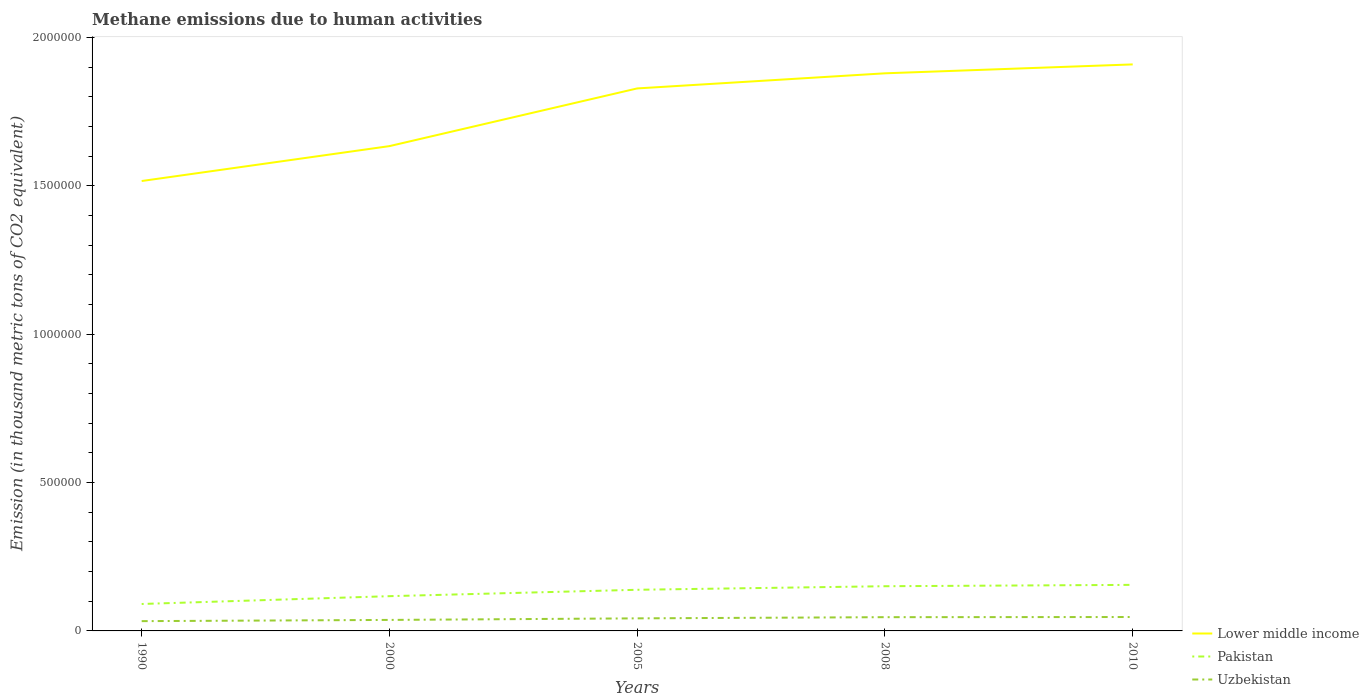How many different coloured lines are there?
Your answer should be very brief. 3. Does the line corresponding to Pakistan intersect with the line corresponding to Lower middle income?
Provide a short and direct response. No. Is the number of lines equal to the number of legend labels?
Offer a very short reply. Yes. Across all years, what is the maximum amount of methane emitted in Lower middle income?
Offer a terse response. 1.52e+06. What is the total amount of methane emitted in Lower middle income in the graph?
Your response must be concise. -2.75e+05. What is the difference between the highest and the second highest amount of methane emitted in Pakistan?
Offer a terse response. 6.44e+04. How many lines are there?
Ensure brevity in your answer.  3. What is the difference between two consecutive major ticks on the Y-axis?
Your response must be concise. 5.00e+05. Does the graph contain any zero values?
Offer a very short reply. No. Where does the legend appear in the graph?
Make the answer very short. Bottom right. What is the title of the graph?
Keep it short and to the point. Methane emissions due to human activities. What is the label or title of the X-axis?
Keep it short and to the point. Years. What is the label or title of the Y-axis?
Provide a short and direct response. Emission (in thousand metric tons of CO2 equivalent). What is the Emission (in thousand metric tons of CO2 equivalent) of Lower middle income in 1990?
Make the answer very short. 1.52e+06. What is the Emission (in thousand metric tons of CO2 equivalent) in Pakistan in 1990?
Keep it short and to the point. 9.08e+04. What is the Emission (in thousand metric tons of CO2 equivalent) in Uzbekistan in 1990?
Your answer should be compact. 3.29e+04. What is the Emission (in thousand metric tons of CO2 equivalent) in Lower middle income in 2000?
Make the answer very short. 1.63e+06. What is the Emission (in thousand metric tons of CO2 equivalent) of Pakistan in 2000?
Your response must be concise. 1.17e+05. What is the Emission (in thousand metric tons of CO2 equivalent) in Uzbekistan in 2000?
Your answer should be compact. 3.71e+04. What is the Emission (in thousand metric tons of CO2 equivalent) of Lower middle income in 2005?
Your answer should be compact. 1.83e+06. What is the Emission (in thousand metric tons of CO2 equivalent) of Pakistan in 2005?
Your answer should be compact. 1.39e+05. What is the Emission (in thousand metric tons of CO2 equivalent) of Uzbekistan in 2005?
Offer a terse response. 4.24e+04. What is the Emission (in thousand metric tons of CO2 equivalent) in Lower middle income in 2008?
Keep it short and to the point. 1.88e+06. What is the Emission (in thousand metric tons of CO2 equivalent) of Pakistan in 2008?
Your answer should be very brief. 1.51e+05. What is the Emission (in thousand metric tons of CO2 equivalent) in Uzbekistan in 2008?
Your answer should be compact. 4.63e+04. What is the Emission (in thousand metric tons of CO2 equivalent) in Lower middle income in 2010?
Provide a short and direct response. 1.91e+06. What is the Emission (in thousand metric tons of CO2 equivalent) of Pakistan in 2010?
Make the answer very short. 1.55e+05. What is the Emission (in thousand metric tons of CO2 equivalent) in Uzbekistan in 2010?
Your answer should be compact. 4.69e+04. Across all years, what is the maximum Emission (in thousand metric tons of CO2 equivalent) in Lower middle income?
Provide a short and direct response. 1.91e+06. Across all years, what is the maximum Emission (in thousand metric tons of CO2 equivalent) in Pakistan?
Your answer should be very brief. 1.55e+05. Across all years, what is the maximum Emission (in thousand metric tons of CO2 equivalent) of Uzbekistan?
Give a very brief answer. 4.69e+04. Across all years, what is the minimum Emission (in thousand metric tons of CO2 equivalent) in Lower middle income?
Make the answer very short. 1.52e+06. Across all years, what is the minimum Emission (in thousand metric tons of CO2 equivalent) of Pakistan?
Offer a terse response. 9.08e+04. Across all years, what is the minimum Emission (in thousand metric tons of CO2 equivalent) in Uzbekistan?
Offer a terse response. 3.29e+04. What is the total Emission (in thousand metric tons of CO2 equivalent) in Lower middle income in the graph?
Provide a succinct answer. 8.77e+06. What is the total Emission (in thousand metric tons of CO2 equivalent) of Pakistan in the graph?
Ensure brevity in your answer.  6.52e+05. What is the total Emission (in thousand metric tons of CO2 equivalent) of Uzbekistan in the graph?
Your response must be concise. 2.06e+05. What is the difference between the Emission (in thousand metric tons of CO2 equivalent) in Lower middle income in 1990 and that in 2000?
Make the answer very short. -1.18e+05. What is the difference between the Emission (in thousand metric tons of CO2 equivalent) of Pakistan in 1990 and that in 2000?
Your answer should be very brief. -2.63e+04. What is the difference between the Emission (in thousand metric tons of CO2 equivalent) of Uzbekistan in 1990 and that in 2000?
Provide a succinct answer. -4131.6. What is the difference between the Emission (in thousand metric tons of CO2 equivalent) of Lower middle income in 1990 and that in 2005?
Provide a short and direct response. -3.12e+05. What is the difference between the Emission (in thousand metric tons of CO2 equivalent) of Pakistan in 1990 and that in 2005?
Make the answer very short. -4.79e+04. What is the difference between the Emission (in thousand metric tons of CO2 equivalent) in Uzbekistan in 1990 and that in 2005?
Give a very brief answer. -9405.4. What is the difference between the Emission (in thousand metric tons of CO2 equivalent) of Lower middle income in 1990 and that in 2008?
Ensure brevity in your answer.  -3.63e+05. What is the difference between the Emission (in thousand metric tons of CO2 equivalent) in Pakistan in 1990 and that in 2008?
Your answer should be compact. -5.98e+04. What is the difference between the Emission (in thousand metric tons of CO2 equivalent) of Uzbekistan in 1990 and that in 2008?
Provide a short and direct response. -1.34e+04. What is the difference between the Emission (in thousand metric tons of CO2 equivalent) of Lower middle income in 1990 and that in 2010?
Offer a terse response. -3.93e+05. What is the difference between the Emission (in thousand metric tons of CO2 equivalent) of Pakistan in 1990 and that in 2010?
Offer a terse response. -6.44e+04. What is the difference between the Emission (in thousand metric tons of CO2 equivalent) of Uzbekistan in 1990 and that in 2010?
Your answer should be compact. -1.39e+04. What is the difference between the Emission (in thousand metric tons of CO2 equivalent) of Lower middle income in 2000 and that in 2005?
Give a very brief answer. -1.94e+05. What is the difference between the Emission (in thousand metric tons of CO2 equivalent) in Pakistan in 2000 and that in 2005?
Your answer should be compact. -2.15e+04. What is the difference between the Emission (in thousand metric tons of CO2 equivalent) in Uzbekistan in 2000 and that in 2005?
Your response must be concise. -5273.8. What is the difference between the Emission (in thousand metric tons of CO2 equivalent) in Lower middle income in 2000 and that in 2008?
Make the answer very short. -2.45e+05. What is the difference between the Emission (in thousand metric tons of CO2 equivalent) of Pakistan in 2000 and that in 2008?
Offer a terse response. -3.35e+04. What is the difference between the Emission (in thousand metric tons of CO2 equivalent) in Uzbekistan in 2000 and that in 2008?
Give a very brief answer. -9259.7. What is the difference between the Emission (in thousand metric tons of CO2 equivalent) in Lower middle income in 2000 and that in 2010?
Your response must be concise. -2.75e+05. What is the difference between the Emission (in thousand metric tons of CO2 equivalent) of Pakistan in 2000 and that in 2010?
Keep it short and to the point. -3.81e+04. What is the difference between the Emission (in thousand metric tons of CO2 equivalent) of Uzbekistan in 2000 and that in 2010?
Offer a terse response. -9783.1. What is the difference between the Emission (in thousand metric tons of CO2 equivalent) in Lower middle income in 2005 and that in 2008?
Keep it short and to the point. -5.09e+04. What is the difference between the Emission (in thousand metric tons of CO2 equivalent) of Pakistan in 2005 and that in 2008?
Offer a very short reply. -1.20e+04. What is the difference between the Emission (in thousand metric tons of CO2 equivalent) of Uzbekistan in 2005 and that in 2008?
Ensure brevity in your answer.  -3985.9. What is the difference between the Emission (in thousand metric tons of CO2 equivalent) of Lower middle income in 2005 and that in 2010?
Make the answer very short. -8.09e+04. What is the difference between the Emission (in thousand metric tons of CO2 equivalent) in Pakistan in 2005 and that in 2010?
Give a very brief answer. -1.66e+04. What is the difference between the Emission (in thousand metric tons of CO2 equivalent) of Uzbekistan in 2005 and that in 2010?
Ensure brevity in your answer.  -4509.3. What is the difference between the Emission (in thousand metric tons of CO2 equivalent) of Lower middle income in 2008 and that in 2010?
Offer a terse response. -3.00e+04. What is the difference between the Emission (in thousand metric tons of CO2 equivalent) in Pakistan in 2008 and that in 2010?
Your answer should be very brief. -4592.5. What is the difference between the Emission (in thousand metric tons of CO2 equivalent) of Uzbekistan in 2008 and that in 2010?
Your answer should be very brief. -523.4. What is the difference between the Emission (in thousand metric tons of CO2 equivalent) of Lower middle income in 1990 and the Emission (in thousand metric tons of CO2 equivalent) of Pakistan in 2000?
Your answer should be compact. 1.40e+06. What is the difference between the Emission (in thousand metric tons of CO2 equivalent) of Lower middle income in 1990 and the Emission (in thousand metric tons of CO2 equivalent) of Uzbekistan in 2000?
Offer a terse response. 1.48e+06. What is the difference between the Emission (in thousand metric tons of CO2 equivalent) of Pakistan in 1990 and the Emission (in thousand metric tons of CO2 equivalent) of Uzbekistan in 2000?
Provide a short and direct response. 5.37e+04. What is the difference between the Emission (in thousand metric tons of CO2 equivalent) of Lower middle income in 1990 and the Emission (in thousand metric tons of CO2 equivalent) of Pakistan in 2005?
Provide a short and direct response. 1.38e+06. What is the difference between the Emission (in thousand metric tons of CO2 equivalent) in Lower middle income in 1990 and the Emission (in thousand metric tons of CO2 equivalent) in Uzbekistan in 2005?
Provide a succinct answer. 1.47e+06. What is the difference between the Emission (in thousand metric tons of CO2 equivalent) of Pakistan in 1990 and the Emission (in thousand metric tons of CO2 equivalent) of Uzbekistan in 2005?
Give a very brief answer. 4.85e+04. What is the difference between the Emission (in thousand metric tons of CO2 equivalent) of Lower middle income in 1990 and the Emission (in thousand metric tons of CO2 equivalent) of Pakistan in 2008?
Your answer should be very brief. 1.37e+06. What is the difference between the Emission (in thousand metric tons of CO2 equivalent) in Lower middle income in 1990 and the Emission (in thousand metric tons of CO2 equivalent) in Uzbekistan in 2008?
Offer a terse response. 1.47e+06. What is the difference between the Emission (in thousand metric tons of CO2 equivalent) of Pakistan in 1990 and the Emission (in thousand metric tons of CO2 equivalent) of Uzbekistan in 2008?
Offer a terse response. 4.45e+04. What is the difference between the Emission (in thousand metric tons of CO2 equivalent) in Lower middle income in 1990 and the Emission (in thousand metric tons of CO2 equivalent) in Pakistan in 2010?
Offer a terse response. 1.36e+06. What is the difference between the Emission (in thousand metric tons of CO2 equivalent) in Lower middle income in 1990 and the Emission (in thousand metric tons of CO2 equivalent) in Uzbekistan in 2010?
Keep it short and to the point. 1.47e+06. What is the difference between the Emission (in thousand metric tons of CO2 equivalent) of Pakistan in 1990 and the Emission (in thousand metric tons of CO2 equivalent) of Uzbekistan in 2010?
Your response must be concise. 4.39e+04. What is the difference between the Emission (in thousand metric tons of CO2 equivalent) of Lower middle income in 2000 and the Emission (in thousand metric tons of CO2 equivalent) of Pakistan in 2005?
Your response must be concise. 1.50e+06. What is the difference between the Emission (in thousand metric tons of CO2 equivalent) in Lower middle income in 2000 and the Emission (in thousand metric tons of CO2 equivalent) in Uzbekistan in 2005?
Your answer should be compact. 1.59e+06. What is the difference between the Emission (in thousand metric tons of CO2 equivalent) in Pakistan in 2000 and the Emission (in thousand metric tons of CO2 equivalent) in Uzbekistan in 2005?
Your answer should be very brief. 7.48e+04. What is the difference between the Emission (in thousand metric tons of CO2 equivalent) in Lower middle income in 2000 and the Emission (in thousand metric tons of CO2 equivalent) in Pakistan in 2008?
Ensure brevity in your answer.  1.48e+06. What is the difference between the Emission (in thousand metric tons of CO2 equivalent) of Lower middle income in 2000 and the Emission (in thousand metric tons of CO2 equivalent) of Uzbekistan in 2008?
Offer a very short reply. 1.59e+06. What is the difference between the Emission (in thousand metric tons of CO2 equivalent) in Pakistan in 2000 and the Emission (in thousand metric tons of CO2 equivalent) in Uzbekistan in 2008?
Make the answer very short. 7.08e+04. What is the difference between the Emission (in thousand metric tons of CO2 equivalent) of Lower middle income in 2000 and the Emission (in thousand metric tons of CO2 equivalent) of Pakistan in 2010?
Your response must be concise. 1.48e+06. What is the difference between the Emission (in thousand metric tons of CO2 equivalent) of Lower middle income in 2000 and the Emission (in thousand metric tons of CO2 equivalent) of Uzbekistan in 2010?
Give a very brief answer. 1.59e+06. What is the difference between the Emission (in thousand metric tons of CO2 equivalent) of Pakistan in 2000 and the Emission (in thousand metric tons of CO2 equivalent) of Uzbekistan in 2010?
Your response must be concise. 7.03e+04. What is the difference between the Emission (in thousand metric tons of CO2 equivalent) in Lower middle income in 2005 and the Emission (in thousand metric tons of CO2 equivalent) in Pakistan in 2008?
Offer a terse response. 1.68e+06. What is the difference between the Emission (in thousand metric tons of CO2 equivalent) of Lower middle income in 2005 and the Emission (in thousand metric tons of CO2 equivalent) of Uzbekistan in 2008?
Your answer should be very brief. 1.78e+06. What is the difference between the Emission (in thousand metric tons of CO2 equivalent) in Pakistan in 2005 and the Emission (in thousand metric tons of CO2 equivalent) in Uzbekistan in 2008?
Ensure brevity in your answer.  9.23e+04. What is the difference between the Emission (in thousand metric tons of CO2 equivalent) of Lower middle income in 2005 and the Emission (in thousand metric tons of CO2 equivalent) of Pakistan in 2010?
Your response must be concise. 1.67e+06. What is the difference between the Emission (in thousand metric tons of CO2 equivalent) in Lower middle income in 2005 and the Emission (in thousand metric tons of CO2 equivalent) in Uzbekistan in 2010?
Provide a short and direct response. 1.78e+06. What is the difference between the Emission (in thousand metric tons of CO2 equivalent) of Pakistan in 2005 and the Emission (in thousand metric tons of CO2 equivalent) of Uzbekistan in 2010?
Your answer should be compact. 9.18e+04. What is the difference between the Emission (in thousand metric tons of CO2 equivalent) of Lower middle income in 2008 and the Emission (in thousand metric tons of CO2 equivalent) of Pakistan in 2010?
Your answer should be compact. 1.72e+06. What is the difference between the Emission (in thousand metric tons of CO2 equivalent) of Lower middle income in 2008 and the Emission (in thousand metric tons of CO2 equivalent) of Uzbekistan in 2010?
Provide a short and direct response. 1.83e+06. What is the difference between the Emission (in thousand metric tons of CO2 equivalent) of Pakistan in 2008 and the Emission (in thousand metric tons of CO2 equivalent) of Uzbekistan in 2010?
Provide a succinct answer. 1.04e+05. What is the average Emission (in thousand metric tons of CO2 equivalent) of Lower middle income per year?
Make the answer very short. 1.75e+06. What is the average Emission (in thousand metric tons of CO2 equivalent) of Pakistan per year?
Keep it short and to the point. 1.30e+05. What is the average Emission (in thousand metric tons of CO2 equivalent) of Uzbekistan per year?
Your answer should be compact. 4.11e+04. In the year 1990, what is the difference between the Emission (in thousand metric tons of CO2 equivalent) of Lower middle income and Emission (in thousand metric tons of CO2 equivalent) of Pakistan?
Give a very brief answer. 1.43e+06. In the year 1990, what is the difference between the Emission (in thousand metric tons of CO2 equivalent) in Lower middle income and Emission (in thousand metric tons of CO2 equivalent) in Uzbekistan?
Your response must be concise. 1.48e+06. In the year 1990, what is the difference between the Emission (in thousand metric tons of CO2 equivalent) of Pakistan and Emission (in thousand metric tons of CO2 equivalent) of Uzbekistan?
Keep it short and to the point. 5.79e+04. In the year 2000, what is the difference between the Emission (in thousand metric tons of CO2 equivalent) of Lower middle income and Emission (in thousand metric tons of CO2 equivalent) of Pakistan?
Your answer should be very brief. 1.52e+06. In the year 2000, what is the difference between the Emission (in thousand metric tons of CO2 equivalent) of Lower middle income and Emission (in thousand metric tons of CO2 equivalent) of Uzbekistan?
Make the answer very short. 1.60e+06. In the year 2000, what is the difference between the Emission (in thousand metric tons of CO2 equivalent) of Pakistan and Emission (in thousand metric tons of CO2 equivalent) of Uzbekistan?
Your answer should be compact. 8.00e+04. In the year 2005, what is the difference between the Emission (in thousand metric tons of CO2 equivalent) in Lower middle income and Emission (in thousand metric tons of CO2 equivalent) in Pakistan?
Keep it short and to the point. 1.69e+06. In the year 2005, what is the difference between the Emission (in thousand metric tons of CO2 equivalent) of Lower middle income and Emission (in thousand metric tons of CO2 equivalent) of Uzbekistan?
Keep it short and to the point. 1.79e+06. In the year 2005, what is the difference between the Emission (in thousand metric tons of CO2 equivalent) in Pakistan and Emission (in thousand metric tons of CO2 equivalent) in Uzbekistan?
Provide a short and direct response. 9.63e+04. In the year 2008, what is the difference between the Emission (in thousand metric tons of CO2 equivalent) in Lower middle income and Emission (in thousand metric tons of CO2 equivalent) in Pakistan?
Your answer should be compact. 1.73e+06. In the year 2008, what is the difference between the Emission (in thousand metric tons of CO2 equivalent) of Lower middle income and Emission (in thousand metric tons of CO2 equivalent) of Uzbekistan?
Offer a very short reply. 1.83e+06. In the year 2008, what is the difference between the Emission (in thousand metric tons of CO2 equivalent) of Pakistan and Emission (in thousand metric tons of CO2 equivalent) of Uzbekistan?
Ensure brevity in your answer.  1.04e+05. In the year 2010, what is the difference between the Emission (in thousand metric tons of CO2 equivalent) in Lower middle income and Emission (in thousand metric tons of CO2 equivalent) in Pakistan?
Ensure brevity in your answer.  1.75e+06. In the year 2010, what is the difference between the Emission (in thousand metric tons of CO2 equivalent) in Lower middle income and Emission (in thousand metric tons of CO2 equivalent) in Uzbekistan?
Give a very brief answer. 1.86e+06. In the year 2010, what is the difference between the Emission (in thousand metric tons of CO2 equivalent) of Pakistan and Emission (in thousand metric tons of CO2 equivalent) of Uzbekistan?
Give a very brief answer. 1.08e+05. What is the ratio of the Emission (in thousand metric tons of CO2 equivalent) of Lower middle income in 1990 to that in 2000?
Provide a succinct answer. 0.93. What is the ratio of the Emission (in thousand metric tons of CO2 equivalent) of Pakistan in 1990 to that in 2000?
Offer a terse response. 0.78. What is the ratio of the Emission (in thousand metric tons of CO2 equivalent) of Uzbekistan in 1990 to that in 2000?
Your response must be concise. 0.89. What is the ratio of the Emission (in thousand metric tons of CO2 equivalent) of Lower middle income in 1990 to that in 2005?
Give a very brief answer. 0.83. What is the ratio of the Emission (in thousand metric tons of CO2 equivalent) of Pakistan in 1990 to that in 2005?
Keep it short and to the point. 0.65. What is the ratio of the Emission (in thousand metric tons of CO2 equivalent) of Uzbekistan in 1990 to that in 2005?
Your answer should be compact. 0.78. What is the ratio of the Emission (in thousand metric tons of CO2 equivalent) in Lower middle income in 1990 to that in 2008?
Give a very brief answer. 0.81. What is the ratio of the Emission (in thousand metric tons of CO2 equivalent) of Pakistan in 1990 to that in 2008?
Offer a terse response. 0.6. What is the ratio of the Emission (in thousand metric tons of CO2 equivalent) of Uzbekistan in 1990 to that in 2008?
Your answer should be very brief. 0.71. What is the ratio of the Emission (in thousand metric tons of CO2 equivalent) of Lower middle income in 1990 to that in 2010?
Your answer should be very brief. 0.79. What is the ratio of the Emission (in thousand metric tons of CO2 equivalent) of Pakistan in 1990 to that in 2010?
Your response must be concise. 0.58. What is the ratio of the Emission (in thousand metric tons of CO2 equivalent) in Uzbekistan in 1990 to that in 2010?
Offer a very short reply. 0.7. What is the ratio of the Emission (in thousand metric tons of CO2 equivalent) in Lower middle income in 2000 to that in 2005?
Your answer should be compact. 0.89. What is the ratio of the Emission (in thousand metric tons of CO2 equivalent) in Pakistan in 2000 to that in 2005?
Provide a short and direct response. 0.84. What is the ratio of the Emission (in thousand metric tons of CO2 equivalent) of Uzbekistan in 2000 to that in 2005?
Ensure brevity in your answer.  0.88. What is the ratio of the Emission (in thousand metric tons of CO2 equivalent) in Lower middle income in 2000 to that in 2008?
Give a very brief answer. 0.87. What is the ratio of the Emission (in thousand metric tons of CO2 equivalent) in Pakistan in 2000 to that in 2008?
Offer a very short reply. 0.78. What is the ratio of the Emission (in thousand metric tons of CO2 equivalent) of Uzbekistan in 2000 to that in 2008?
Your response must be concise. 0.8. What is the ratio of the Emission (in thousand metric tons of CO2 equivalent) of Lower middle income in 2000 to that in 2010?
Provide a short and direct response. 0.86. What is the ratio of the Emission (in thousand metric tons of CO2 equivalent) of Pakistan in 2000 to that in 2010?
Provide a succinct answer. 0.75. What is the ratio of the Emission (in thousand metric tons of CO2 equivalent) of Uzbekistan in 2000 to that in 2010?
Offer a very short reply. 0.79. What is the ratio of the Emission (in thousand metric tons of CO2 equivalent) in Lower middle income in 2005 to that in 2008?
Your answer should be very brief. 0.97. What is the ratio of the Emission (in thousand metric tons of CO2 equivalent) of Pakistan in 2005 to that in 2008?
Offer a terse response. 0.92. What is the ratio of the Emission (in thousand metric tons of CO2 equivalent) in Uzbekistan in 2005 to that in 2008?
Your answer should be compact. 0.91. What is the ratio of the Emission (in thousand metric tons of CO2 equivalent) in Lower middle income in 2005 to that in 2010?
Offer a terse response. 0.96. What is the ratio of the Emission (in thousand metric tons of CO2 equivalent) of Pakistan in 2005 to that in 2010?
Ensure brevity in your answer.  0.89. What is the ratio of the Emission (in thousand metric tons of CO2 equivalent) of Uzbekistan in 2005 to that in 2010?
Give a very brief answer. 0.9. What is the ratio of the Emission (in thousand metric tons of CO2 equivalent) of Lower middle income in 2008 to that in 2010?
Keep it short and to the point. 0.98. What is the ratio of the Emission (in thousand metric tons of CO2 equivalent) in Pakistan in 2008 to that in 2010?
Ensure brevity in your answer.  0.97. What is the ratio of the Emission (in thousand metric tons of CO2 equivalent) in Uzbekistan in 2008 to that in 2010?
Keep it short and to the point. 0.99. What is the difference between the highest and the second highest Emission (in thousand metric tons of CO2 equivalent) in Lower middle income?
Give a very brief answer. 3.00e+04. What is the difference between the highest and the second highest Emission (in thousand metric tons of CO2 equivalent) in Pakistan?
Provide a succinct answer. 4592.5. What is the difference between the highest and the second highest Emission (in thousand metric tons of CO2 equivalent) of Uzbekistan?
Your answer should be compact. 523.4. What is the difference between the highest and the lowest Emission (in thousand metric tons of CO2 equivalent) of Lower middle income?
Make the answer very short. 3.93e+05. What is the difference between the highest and the lowest Emission (in thousand metric tons of CO2 equivalent) in Pakistan?
Give a very brief answer. 6.44e+04. What is the difference between the highest and the lowest Emission (in thousand metric tons of CO2 equivalent) in Uzbekistan?
Give a very brief answer. 1.39e+04. 